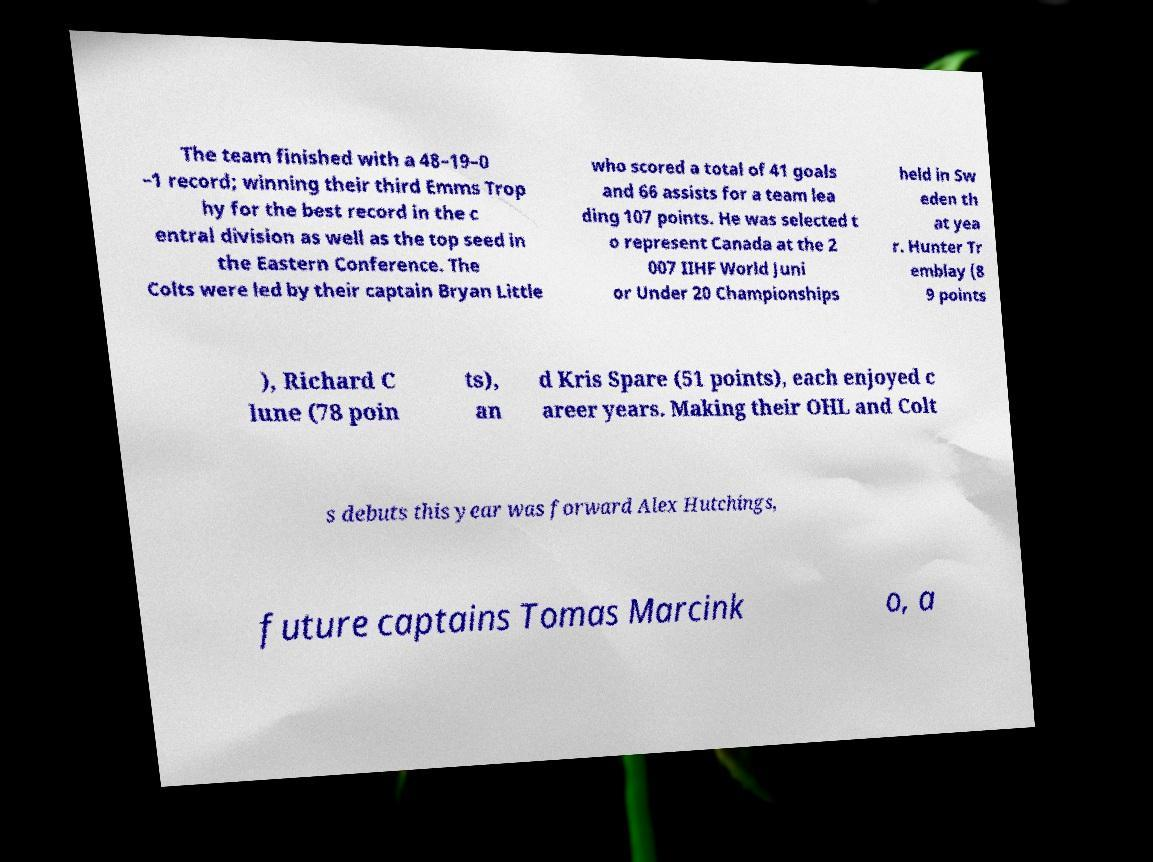Can you accurately transcribe the text from the provided image for me? The team finished with a 48–19–0 –1 record; winning their third Emms Trop hy for the best record in the c entral division as well as the top seed in the Eastern Conference. The Colts were led by their captain Bryan Little who scored a total of 41 goals and 66 assists for a team lea ding 107 points. He was selected t o represent Canada at the 2 007 IIHF World Juni or Under 20 Championships held in Sw eden th at yea r. Hunter Tr emblay (8 9 points ), Richard C lune (78 poin ts), an d Kris Spare (51 points), each enjoyed c areer years. Making their OHL and Colt s debuts this year was forward Alex Hutchings, future captains Tomas Marcink o, a 